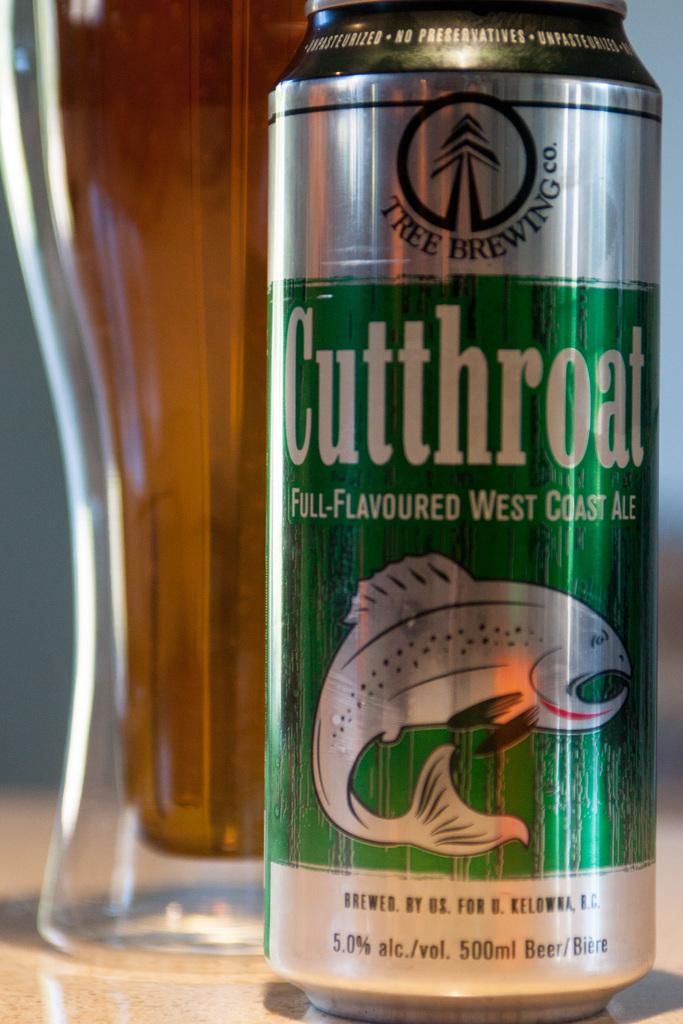How much alcohol does this contain?
Offer a terse response. 5.0%. 